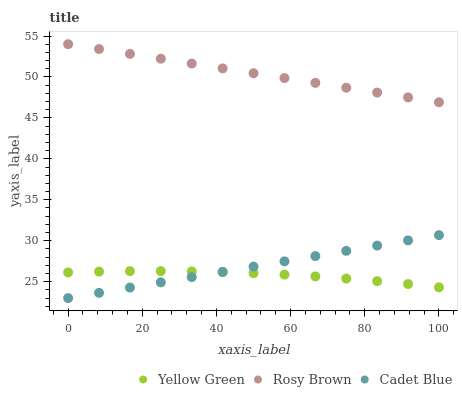Does Yellow Green have the minimum area under the curve?
Answer yes or no. Yes. Does Rosy Brown have the maximum area under the curve?
Answer yes or no. Yes. Does Rosy Brown have the minimum area under the curve?
Answer yes or no. No. Does Yellow Green have the maximum area under the curve?
Answer yes or no. No. Is Rosy Brown the smoothest?
Answer yes or no. Yes. Is Yellow Green the roughest?
Answer yes or no. Yes. Is Yellow Green the smoothest?
Answer yes or no. No. Is Rosy Brown the roughest?
Answer yes or no. No. Does Cadet Blue have the lowest value?
Answer yes or no. Yes. Does Yellow Green have the lowest value?
Answer yes or no. No. Does Rosy Brown have the highest value?
Answer yes or no. Yes. Does Yellow Green have the highest value?
Answer yes or no. No. Is Yellow Green less than Rosy Brown?
Answer yes or no. Yes. Is Rosy Brown greater than Yellow Green?
Answer yes or no. Yes. Does Cadet Blue intersect Yellow Green?
Answer yes or no. Yes. Is Cadet Blue less than Yellow Green?
Answer yes or no. No. Is Cadet Blue greater than Yellow Green?
Answer yes or no. No. Does Yellow Green intersect Rosy Brown?
Answer yes or no. No. 